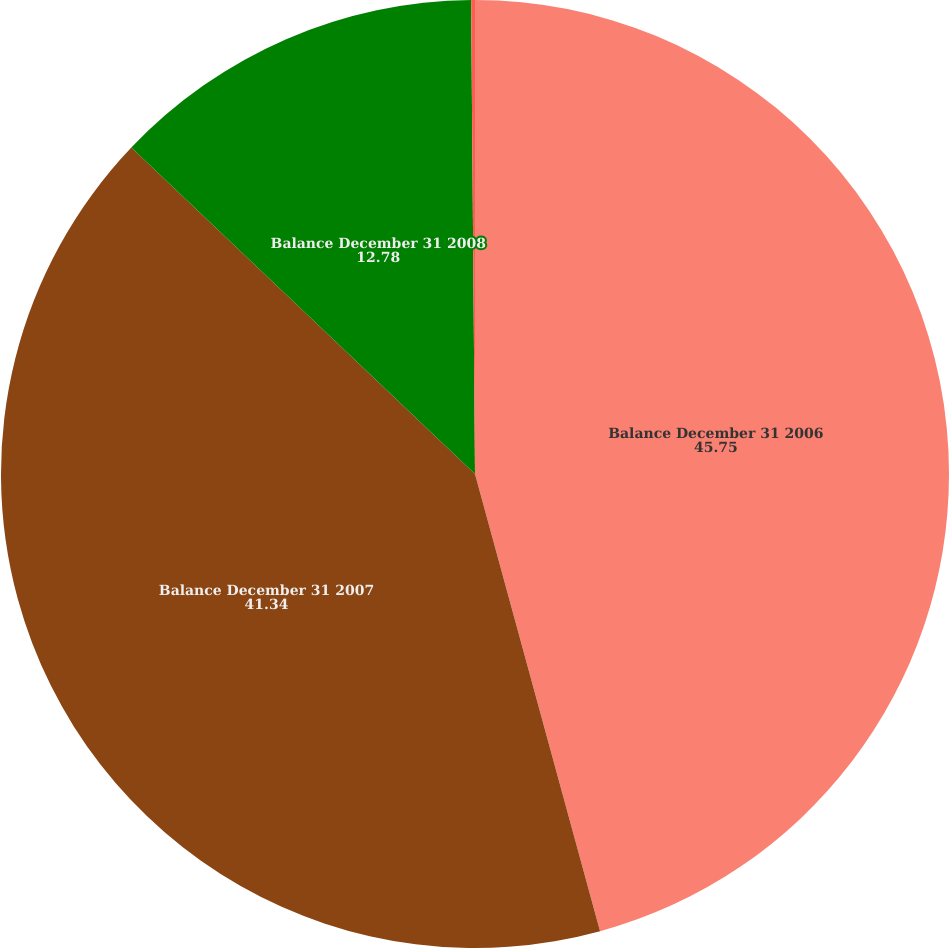Convert chart. <chart><loc_0><loc_0><loc_500><loc_500><pie_chart><fcel>Balance December 31 2006<fcel>Balance December 31 2007<fcel>Balance December 31 2008<fcel>Cumulative impact of the<nl><fcel>45.75%<fcel>41.34%<fcel>12.78%<fcel>0.13%<nl></chart> 